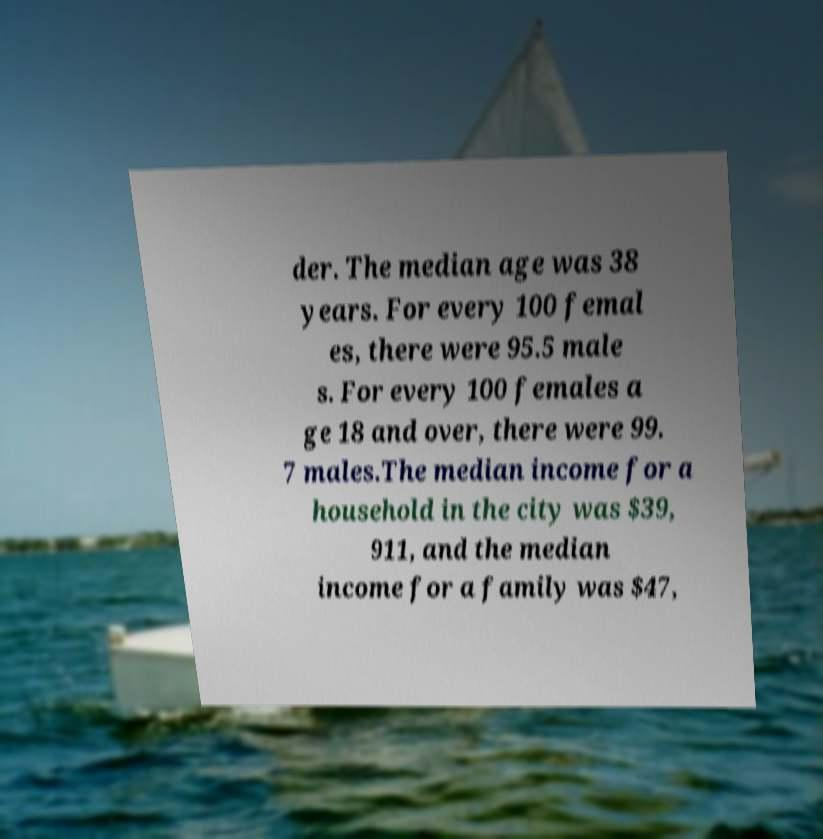Could you assist in decoding the text presented in this image and type it out clearly? der. The median age was 38 years. For every 100 femal es, there were 95.5 male s. For every 100 females a ge 18 and over, there were 99. 7 males.The median income for a household in the city was $39, 911, and the median income for a family was $47, 